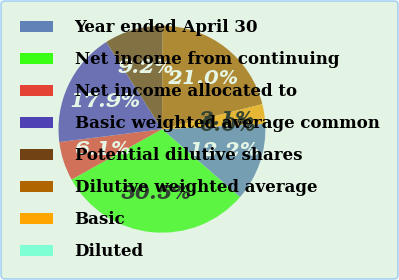Convert chart to OTSL. <chart><loc_0><loc_0><loc_500><loc_500><pie_chart><fcel>Year ended April 30<fcel>Net income from continuing<fcel>Net income allocated to<fcel>Basic weighted average common<fcel>Potential dilutive shares<fcel>Dilutive weighted average<fcel>Basic<fcel>Diluted<nl><fcel>12.22%<fcel>30.52%<fcel>6.11%<fcel>17.94%<fcel>9.17%<fcel>20.99%<fcel>3.06%<fcel>0.0%<nl></chart> 